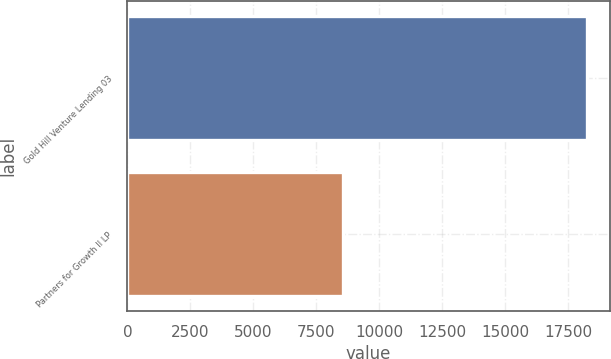<chart> <loc_0><loc_0><loc_500><loc_500><bar_chart><fcel>Gold Hill Venture Lending 03<fcel>Partners for Growth II LP<nl><fcel>18234<fcel>8559<nl></chart> 